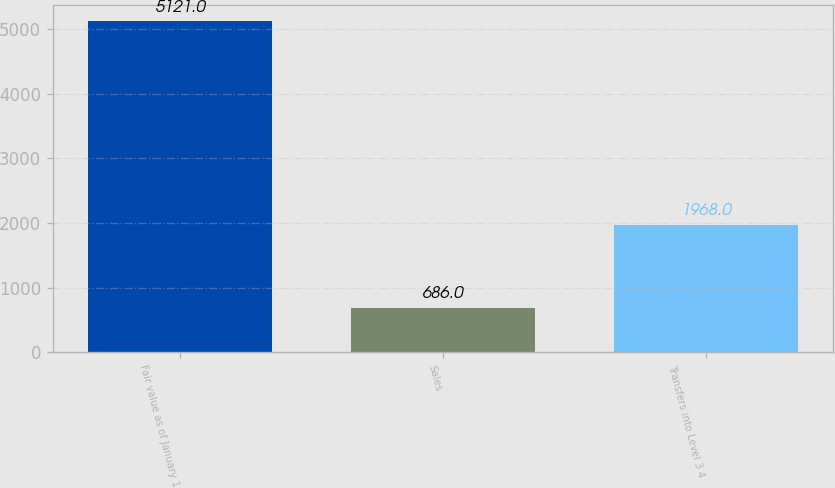<chart> <loc_0><loc_0><loc_500><loc_500><bar_chart><fcel>Fair value as of January 1<fcel>Sales<fcel>Transfers into Level 3 4<nl><fcel>5121<fcel>686<fcel>1968<nl></chart> 